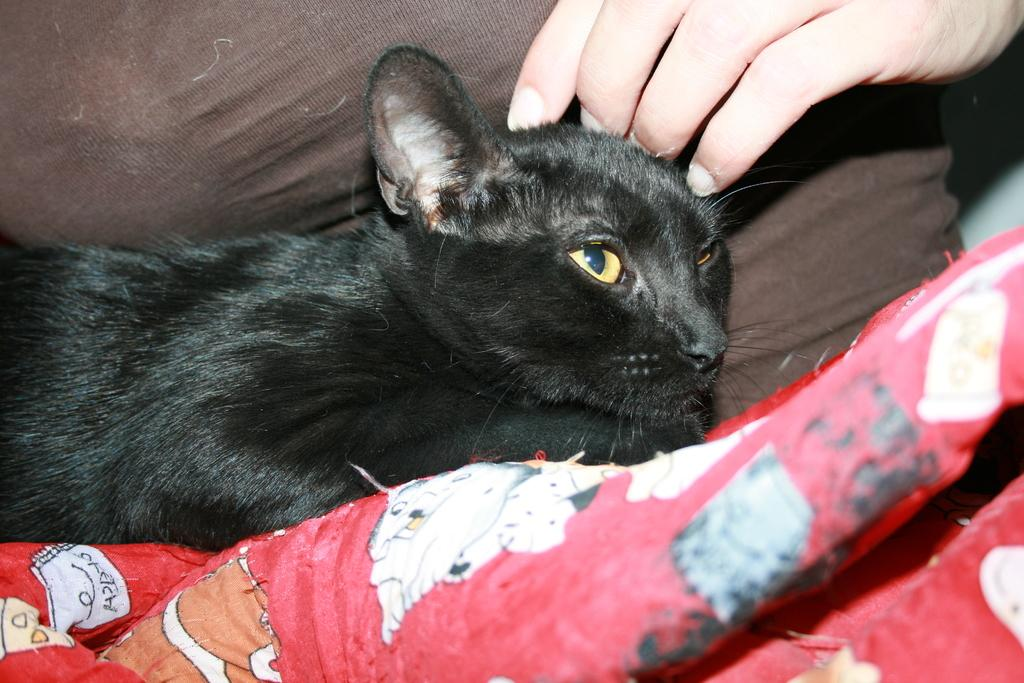What animal is lying on the lap of a person in the image? There is a cat lying on the lap of a person in the image. What is visible at the bottom of the image? There is a bed sheet at the bottom of the image. Where is the person located in the image? There is a person at the top of the image. What type of seat is the cat sitting on in the image? There is no seat present in the image; the cat is lying on the lap of a person. What liquid can be seen being poured in the image? There is no liquid being poured in the image. 